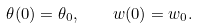Convert formula to latex. <formula><loc_0><loc_0><loc_500><loc_500>\theta ( 0 ) = \theta _ { 0 } , \quad w ( 0 ) = w _ { 0 } .</formula> 